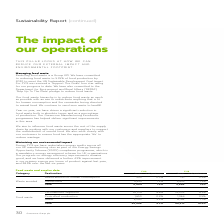According to Greencore Group Plc's financial document, What is the total food waste for FY19? According to the financial document, 34,908. The relevant text states: "Total 34,908 9.2% 40,912 10.5%..." Also, What is the total food waste for FY18? According to the financial document, 40,912. The relevant text states: "Total 34,908 9.2% 40,912 10.5%..." Also, What was the animal feed waste avoided in FY19? According to the financial document, 4,454. The relevant text states: "Animal feed 4,454 1.2% 4,895 1.3%..." Also, can you calculate: What was the change in the animal feed waste avoided from FY18 to FY19? Based on the calculation: 4,454 - 4,895, the result is -441. This is based on the information: "Animal feed 4,454 1.2% 4,895 1.3% Animal feed 4,454 1.2% 4,895 1.3%..." The key data points involved are: 4,454, 4,895. Also, can you calculate: What is the average redistribution for human consumption for FY18 and FY19? To answer this question, I need to perform calculations using the financial data. The calculation is: (950 + 791) / 2, which equals 870.5. This is based on the information: "Redistribution for human consumption 950 0.3% 791 0.2% Redistribution for human consumption 950 0.3% 791 0.2%..." The key data points involved are: 791, 950. Also, can you calculate: What is the average controlled combustion food waste for FY18 and FY19? To answer this question, I need to perform calculations using the financial data. The calculation is: (1,650 + 1,964) / 2, which equals 1807. This is based on the information: "Controlled combustion 1,650 0.4% 1,964 0.5% Controlled combustion 1,650 0.4% 1,964 0.5%..." The key data points involved are: 1,650, 1,964. 